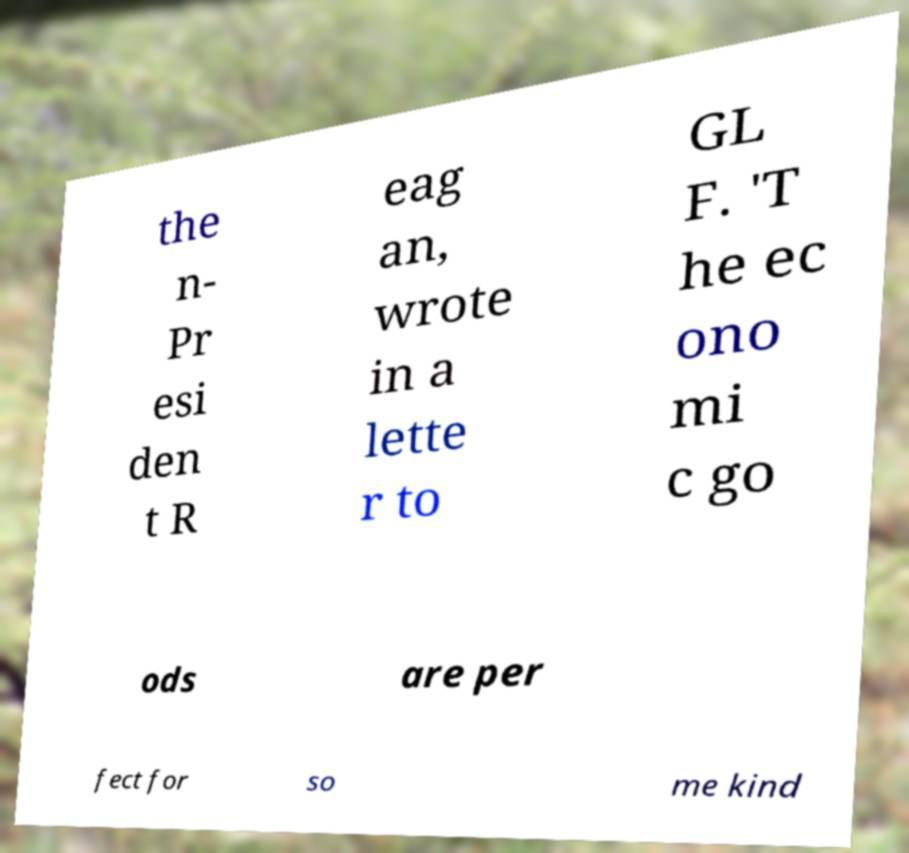Can you accurately transcribe the text from the provided image for me? the n- Pr esi den t R eag an, wrote in a lette r to GL F. 'T he ec ono mi c go ods are per fect for so me kind 